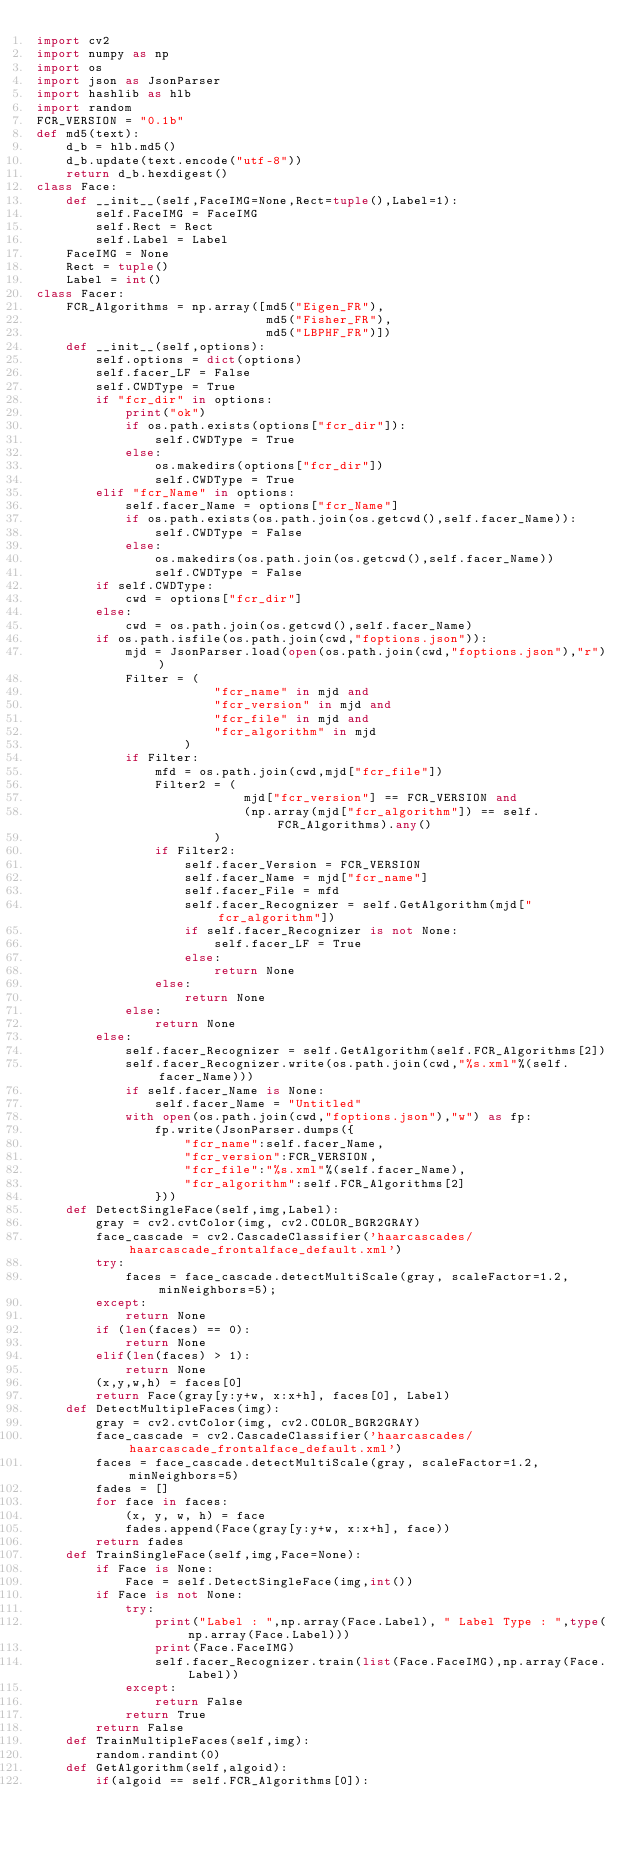Convert code to text. <code><loc_0><loc_0><loc_500><loc_500><_Python_>import cv2
import numpy as np
import os
import json as JsonParser
import hashlib as hlb
import random
FCR_VERSION = "0.1b"
def md5(text):
    d_b = hlb.md5()
    d_b.update(text.encode("utf-8"))
    return d_b.hexdigest()
class Face:
    def __init__(self,FaceIMG=None,Rect=tuple(),Label=1):
        self.FaceIMG = FaceIMG
        self.Rect = Rect
        self.Label = Label
    FaceIMG = None
    Rect = tuple()
    Label = int()
class Facer:
    FCR_Algorithms = np.array([md5("Eigen_FR"),
                               md5("Fisher_FR"),
                               md5("LBPHF_FR")])
    def __init__(self,options):
        self.options = dict(options)
        self.facer_LF = False
        self.CWDType = True
        if "fcr_dir" in options:
            print("ok")
            if os.path.exists(options["fcr_dir"]):
                self.CWDType = True
            else:
                os.makedirs(options["fcr_dir"])
                self.CWDType = True
        elif "fcr_Name" in options:
            self.facer_Name = options["fcr_Name"]
            if os.path.exists(os.path.join(os.getcwd(),self.facer_Name)):
                self.CWDType = False
            else:
                os.makedirs(os.path.join(os.getcwd(),self.facer_Name))
                self.CWDType = False
        if self.CWDType:
            cwd = options["fcr_dir"]
        else:
            cwd = os.path.join(os.getcwd(),self.facer_Name)            
        if os.path.isfile(os.path.join(cwd,"foptions.json")):
            mjd = JsonParser.load(open(os.path.join(cwd,"foptions.json"),"r"))
            Filter = (
                        "fcr_name" in mjd and
                        "fcr_version" in mjd and
                        "fcr_file" in mjd and
                        "fcr_algorithm" in mjd
                    )
            if Filter:
                mfd = os.path.join(cwd,mjd["fcr_file"])
                Filter2 = (
                            mjd["fcr_version"] == FCR_VERSION and
                            (np.array(mjd["fcr_algorithm"]) == self.FCR_Algorithms).any()
                        )
                if Filter2:
                    self.facer_Version = FCR_VERSION
                    self.facer_Name = mjd["fcr_name"]
                    self.facer_File = mfd
                    self.facer_Recognizer = self.GetAlgorithm(mjd["fcr_algorithm"])
                    if self.facer_Recognizer is not None:
                        self.facer_LF = True
                    else:
                        return None
                else:
                    return None
            else:
                return None
        else:
            self.facer_Recognizer = self.GetAlgorithm(self.FCR_Algorithms[2])
            self.facer_Recognizer.write(os.path.join(cwd,"%s.xml"%(self.facer_Name)))
            if self.facer_Name is None:
                self.facer_Name = "Untitled"
            with open(os.path.join(cwd,"foptions.json"),"w") as fp:
                fp.write(JsonParser.dumps({
                    "fcr_name":self.facer_Name,
                    "fcr_version":FCR_VERSION,
                    "fcr_file":"%s.xml"%(self.facer_Name),
                    "fcr_algorithm":self.FCR_Algorithms[2]
                }))
    def DetectSingleFace(self,img,Label):
        gray = cv2.cvtColor(img, cv2.COLOR_BGR2GRAY)
        face_cascade = cv2.CascadeClassifier('haarcascades/haarcascade_frontalface_default.xml')
        try:
            faces = face_cascade.detectMultiScale(gray, scaleFactor=1.2, minNeighbors=5);
        except:
            return None
        if (len(faces) == 0):
            return None
        elif(len(faces) > 1):
            return None
        (x,y,w,h) = faces[0]
        return Face(gray[y:y+w, x:x+h], faces[0], Label)
    def DetectMultipleFaces(img):
        gray = cv2.cvtColor(img, cv2.COLOR_BGR2GRAY)
        face_cascade = cv2.CascadeClassifier('haarcascades/haarcascade_frontalface_default.xml')
        faces = face_cascade.detectMultiScale(gray, scaleFactor=1.2, minNeighbors=5)
        fades = []
        for face in faces:
            (x, y, w, h) = face
            fades.append(Face(gray[y:y+w, x:x+h], face))
        return fades
    def TrainSingleFace(self,img,Face=None):
        if Face is None:
            Face = self.DetectSingleFace(img,int())
        if Face is not None:
            try:
                print("Label : ",np.array(Face.Label), " Label Type : ",type(np.array(Face.Label)))
                print(Face.FaceIMG)
                self.facer_Recognizer.train(list(Face.FaceIMG),np.array(Face.Label))
            except:
                return False
            return True
        return False
    def TrainMultipleFaces(self,img):
        random.randint(0)
    def GetAlgorithm(self,algoid):
        if(algoid == self.FCR_Algorithms[0]):</code> 